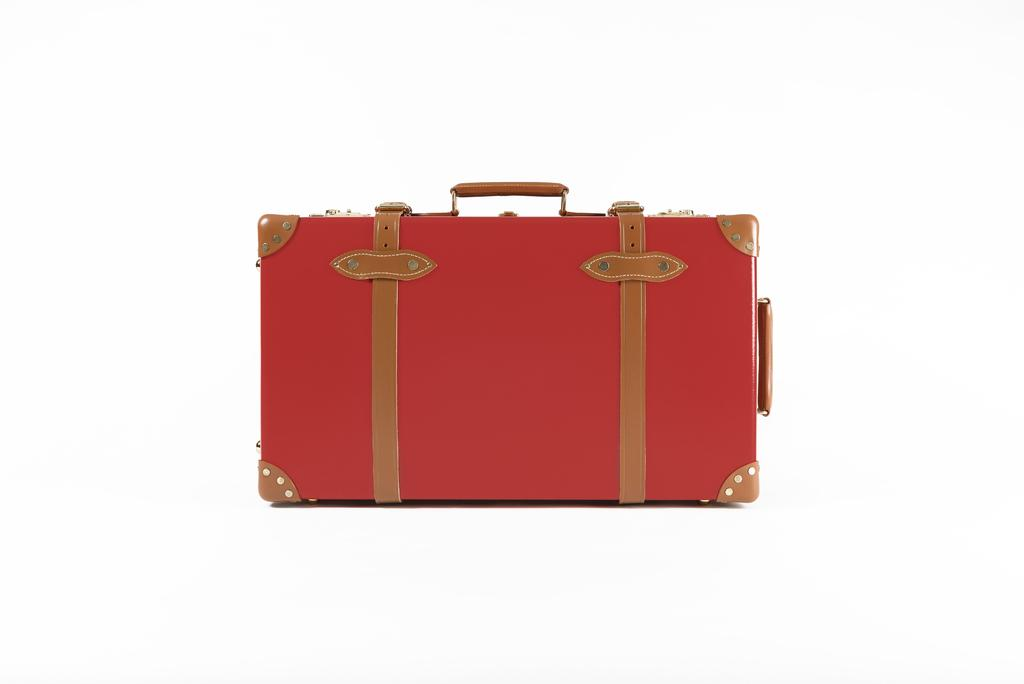What color is the suitcase in the picture? The suitcase in the picture is red. How many belts are on the suitcase? The suitcase has two belts. What color is the background of the image? The background of the image is white. Is the maid carrying a tray with a parcel in the image? There is no maid or tray with a parcel present in the image; it only features a red suitcase with two belts against a white background. 